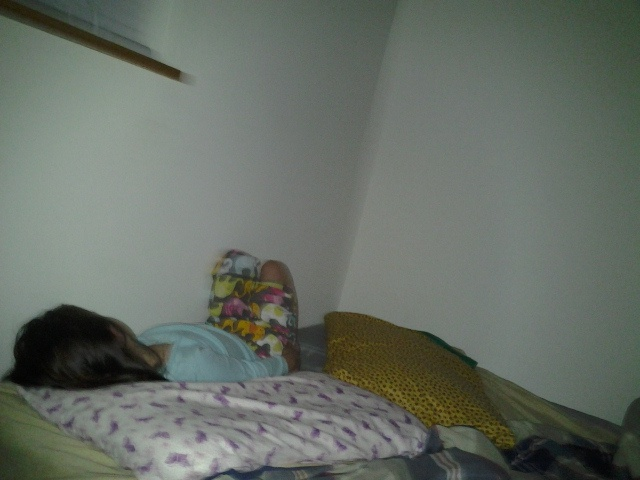Describe the objects in this image and their specific colors. I can see bed in black, gray, darkgray, and darkgreen tones and people in black, gray, and darkgreen tones in this image. 